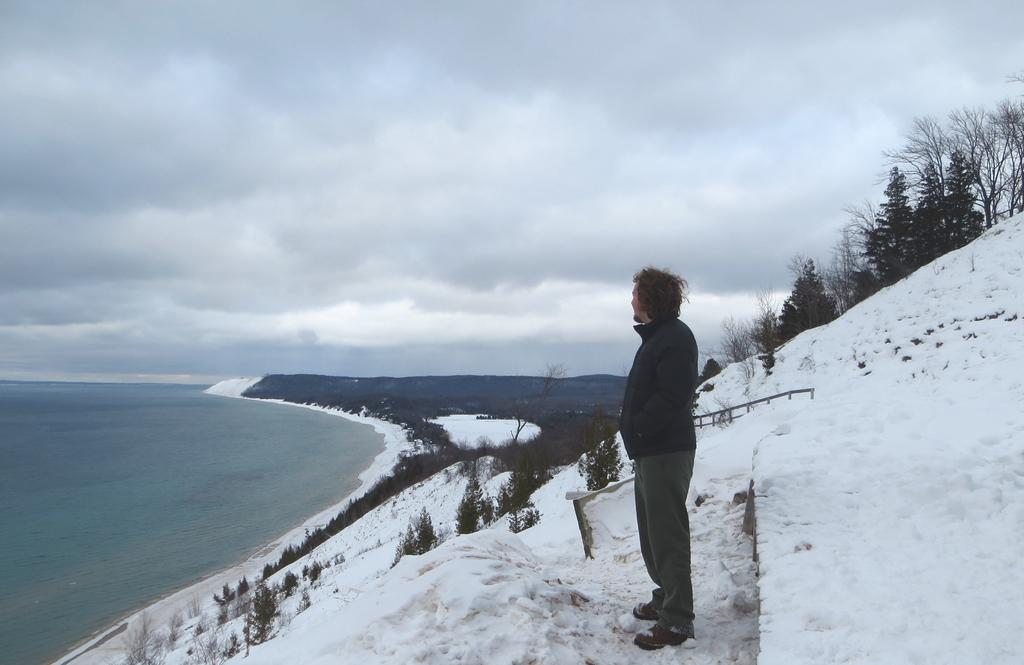What is the main subject in the image? There is a person standing in the image. What is the condition of the ground in the image? The ground is covered with snow. What can be seen in the background of the image? There are trees visible in the background. What type of landscape is visible at the bottom of the image? There is a sea shore at the bottom of the image. What type of acoustics can be heard from the person's clothing in the image? There is no information about the person's clothing or any acoustics in the image. --- Facts: 1. There is a car in the image. 2. The car is red. 3. The car has four wheels. 4. There is a road in the image. 5. The road is paved. Absurd Topics: parrot, dance, ocean Conversation: What is the main subject in the image? There is a car in the image. What color is the car? The car is red. How many wheels does the car have? The car has four wheels. What type of surface is visible in the image? There is a road in the image, and it is paved. Reasoning: Let's think step by step in order to produce the conversation. We start by identifying the main subject in the image, which is the car. Then, we describe the color of the car, which is red. Next, we mention the number of wheels the car has, which is four. Finally, we focus on the surface visible in the image, which is a paved road. Each question is designed to elicit a specific detail about the image that is known from the provided facts. Absurd Question/Answer: Can you see a parrot dancing on the ocean in the image? No, there is no parrot, dancing, or ocean present in the image. 